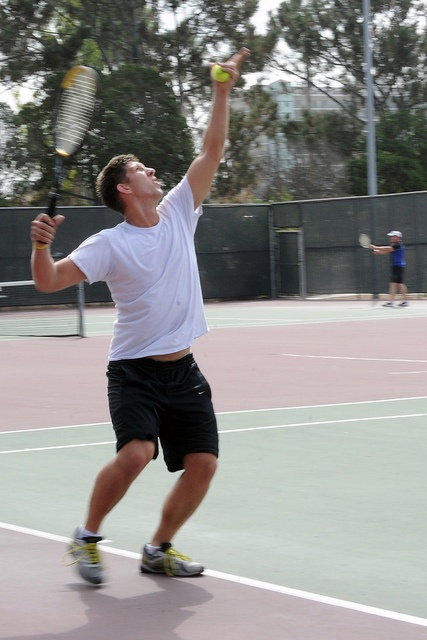Describe the objects in this image and their specific colors. I can see people in lightgray, black, darkgray, and brown tones, tennis racket in lightgray, darkgray, gray, and black tones, people in lightgray, black, gray, and navy tones, sports ball in lightgray, olive, and khaki tones, and tennis racket in lightgray, darkgray, and gray tones in this image. 